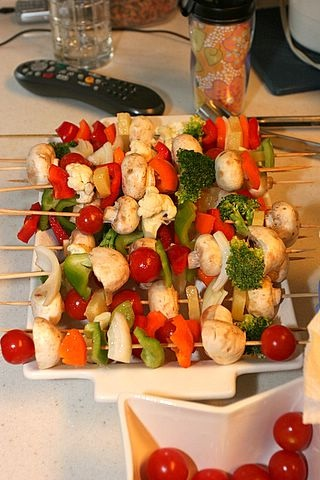Describe the objects in this image and their specific colors. I can see dining table in tan, maroon, and brown tones, dining table in maroon, black, tan, and gray tones, remote in tan, black, gray, and maroon tones, cup in tan, gray, and maroon tones, and carrot in tan, red, brown, and maroon tones in this image. 